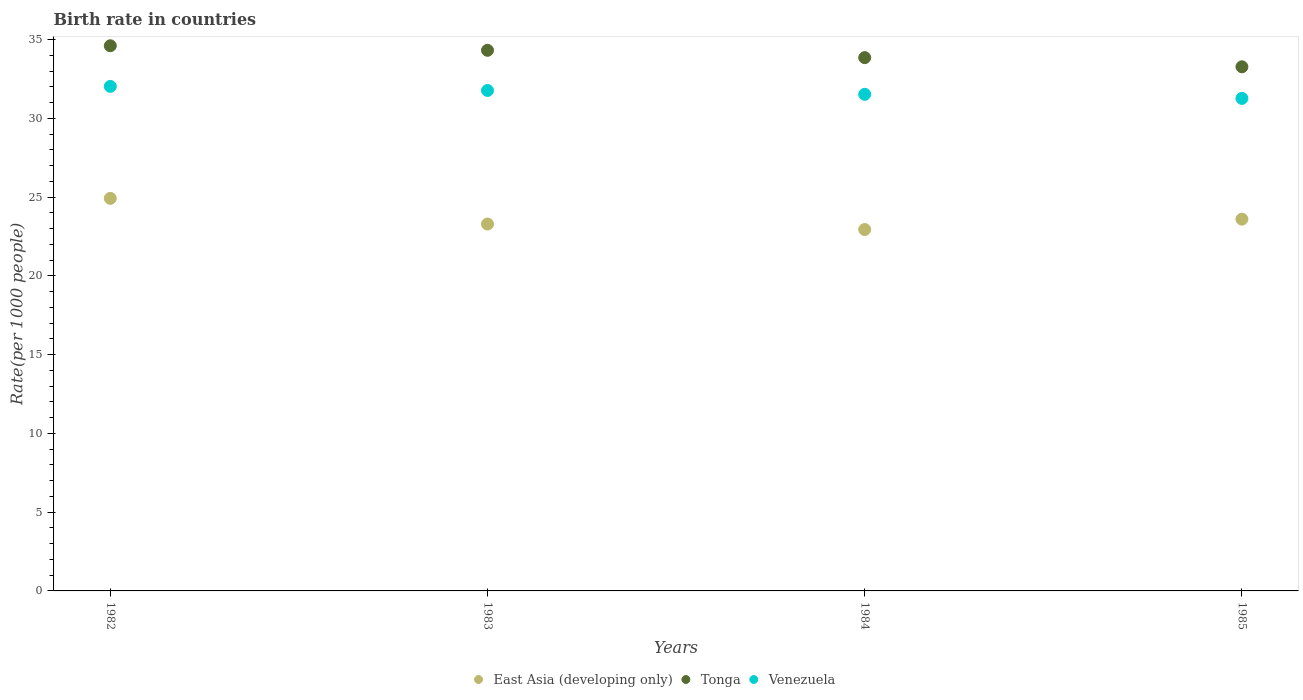How many different coloured dotlines are there?
Keep it short and to the point. 3. What is the birth rate in Tonga in 1983?
Your answer should be compact. 34.32. Across all years, what is the maximum birth rate in Venezuela?
Give a very brief answer. 32.03. Across all years, what is the minimum birth rate in Venezuela?
Offer a terse response. 31.27. In which year was the birth rate in Venezuela maximum?
Keep it short and to the point. 1982. In which year was the birth rate in Tonga minimum?
Your answer should be very brief. 1985. What is the total birth rate in Tonga in the graph?
Keep it short and to the point. 136.06. What is the difference between the birth rate in East Asia (developing only) in 1983 and that in 1985?
Provide a short and direct response. -0.31. What is the difference between the birth rate in Venezuela in 1984 and the birth rate in Tonga in 1982?
Your answer should be compact. -3.08. What is the average birth rate in Venezuela per year?
Your answer should be compact. 31.65. In the year 1983, what is the difference between the birth rate in Venezuela and birth rate in East Asia (developing only)?
Give a very brief answer. 8.48. What is the ratio of the birth rate in East Asia (developing only) in 1982 to that in 1985?
Provide a short and direct response. 1.06. Is the birth rate in Tonga in 1983 less than that in 1984?
Keep it short and to the point. No. Is the difference between the birth rate in Venezuela in 1982 and 1985 greater than the difference between the birth rate in East Asia (developing only) in 1982 and 1985?
Provide a short and direct response. No. What is the difference between the highest and the second highest birth rate in Tonga?
Keep it short and to the point. 0.29. What is the difference between the highest and the lowest birth rate in East Asia (developing only)?
Give a very brief answer. 1.98. In how many years, is the birth rate in Tonga greater than the average birth rate in Tonga taken over all years?
Your answer should be compact. 2. Is the sum of the birth rate in Tonga in 1982 and 1983 greater than the maximum birth rate in East Asia (developing only) across all years?
Ensure brevity in your answer.  Yes. Is it the case that in every year, the sum of the birth rate in Tonga and birth rate in East Asia (developing only)  is greater than the birth rate in Venezuela?
Provide a succinct answer. Yes. Does the birth rate in Tonga monotonically increase over the years?
Offer a terse response. No. How many dotlines are there?
Give a very brief answer. 3. How many years are there in the graph?
Make the answer very short. 4. Are the values on the major ticks of Y-axis written in scientific E-notation?
Your answer should be very brief. No. Where does the legend appear in the graph?
Provide a succinct answer. Bottom center. How are the legend labels stacked?
Offer a terse response. Horizontal. What is the title of the graph?
Your answer should be compact. Birth rate in countries. Does "Mozambique" appear as one of the legend labels in the graph?
Provide a succinct answer. No. What is the label or title of the Y-axis?
Offer a very short reply. Rate(per 1000 people). What is the Rate(per 1000 people) of East Asia (developing only) in 1982?
Your answer should be very brief. 24.92. What is the Rate(per 1000 people) of Tonga in 1982?
Provide a succinct answer. 34.61. What is the Rate(per 1000 people) of Venezuela in 1982?
Give a very brief answer. 32.03. What is the Rate(per 1000 people) of East Asia (developing only) in 1983?
Keep it short and to the point. 23.29. What is the Rate(per 1000 people) of Tonga in 1983?
Ensure brevity in your answer.  34.32. What is the Rate(per 1000 people) of Venezuela in 1983?
Make the answer very short. 31.77. What is the Rate(per 1000 people) in East Asia (developing only) in 1984?
Provide a short and direct response. 22.94. What is the Rate(per 1000 people) of Tonga in 1984?
Give a very brief answer. 33.86. What is the Rate(per 1000 people) in Venezuela in 1984?
Keep it short and to the point. 31.53. What is the Rate(per 1000 people) of East Asia (developing only) in 1985?
Give a very brief answer. 23.6. What is the Rate(per 1000 people) of Tonga in 1985?
Offer a very short reply. 33.27. What is the Rate(per 1000 people) in Venezuela in 1985?
Provide a short and direct response. 31.27. Across all years, what is the maximum Rate(per 1000 people) of East Asia (developing only)?
Keep it short and to the point. 24.92. Across all years, what is the maximum Rate(per 1000 people) in Tonga?
Provide a succinct answer. 34.61. Across all years, what is the maximum Rate(per 1000 people) of Venezuela?
Provide a succinct answer. 32.03. Across all years, what is the minimum Rate(per 1000 people) of East Asia (developing only)?
Your answer should be very brief. 22.94. Across all years, what is the minimum Rate(per 1000 people) in Tonga?
Your response must be concise. 33.27. Across all years, what is the minimum Rate(per 1000 people) of Venezuela?
Offer a terse response. 31.27. What is the total Rate(per 1000 people) in East Asia (developing only) in the graph?
Keep it short and to the point. 94.76. What is the total Rate(per 1000 people) of Tonga in the graph?
Provide a short and direct response. 136.06. What is the total Rate(per 1000 people) in Venezuela in the graph?
Make the answer very short. 126.6. What is the difference between the Rate(per 1000 people) of East Asia (developing only) in 1982 and that in 1983?
Your answer should be very brief. 1.63. What is the difference between the Rate(per 1000 people) in Tonga in 1982 and that in 1983?
Provide a short and direct response. 0.29. What is the difference between the Rate(per 1000 people) in Venezuela in 1982 and that in 1983?
Your answer should be very brief. 0.26. What is the difference between the Rate(per 1000 people) of East Asia (developing only) in 1982 and that in 1984?
Offer a terse response. 1.98. What is the difference between the Rate(per 1000 people) of Tonga in 1982 and that in 1984?
Provide a succinct answer. 0.75. What is the difference between the Rate(per 1000 people) in Venezuela in 1982 and that in 1984?
Your response must be concise. 0.5. What is the difference between the Rate(per 1000 people) in East Asia (developing only) in 1982 and that in 1985?
Offer a terse response. 1.32. What is the difference between the Rate(per 1000 people) in Tonga in 1982 and that in 1985?
Provide a succinct answer. 1.33. What is the difference between the Rate(per 1000 people) of Venezuela in 1982 and that in 1985?
Your answer should be compact. 0.76. What is the difference between the Rate(per 1000 people) of East Asia (developing only) in 1983 and that in 1984?
Provide a short and direct response. 0.35. What is the difference between the Rate(per 1000 people) of Tonga in 1983 and that in 1984?
Offer a terse response. 0.47. What is the difference between the Rate(per 1000 people) in Venezuela in 1983 and that in 1984?
Provide a short and direct response. 0.24. What is the difference between the Rate(per 1000 people) in East Asia (developing only) in 1983 and that in 1985?
Your answer should be compact. -0.31. What is the difference between the Rate(per 1000 people) of Tonga in 1983 and that in 1985?
Ensure brevity in your answer.  1.05. What is the difference between the Rate(per 1000 people) of Venezuela in 1983 and that in 1985?
Ensure brevity in your answer.  0.5. What is the difference between the Rate(per 1000 people) of East Asia (developing only) in 1984 and that in 1985?
Provide a short and direct response. -0.66. What is the difference between the Rate(per 1000 people) in Tonga in 1984 and that in 1985?
Your answer should be compact. 0.58. What is the difference between the Rate(per 1000 people) in Venezuela in 1984 and that in 1985?
Your response must be concise. 0.26. What is the difference between the Rate(per 1000 people) of East Asia (developing only) in 1982 and the Rate(per 1000 people) of Tonga in 1983?
Offer a very short reply. -9.4. What is the difference between the Rate(per 1000 people) of East Asia (developing only) in 1982 and the Rate(per 1000 people) of Venezuela in 1983?
Your answer should be very brief. -6.85. What is the difference between the Rate(per 1000 people) of Tonga in 1982 and the Rate(per 1000 people) of Venezuela in 1983?
Give a very brief answer. 2.84. What is the difference between the Rate(per 1000 people) of East Asia (developing only) in 1982 and the Rate(per 1000 people) of Tonga in 1984?
Provide a succinct answer. -8.93. What is the difference between the Rate(per 1000 people) in East Asia (developing only) in 1982 and the Rate(per 1000 people) in Venezuela in 1984?
Offer a very short reply. -6.6. What is the difference between the Rate(per 1000 people) in Tonga in 1982 and the Rate(per 1000 people) in Venezuela in 1984?
Provide a succinct answer. 3.08. What is the difference between the Rate(per 1000 people) in East Asia (developing only) in 1982 and the Rate(per 1000 people) in Tonga in 1985?
Offer a very short reply. -8.35. What is the difference between the Rate(per 1000 people) of East Asia (developing only) in 1982 and the Rate(per 1000 people) of Venezuela in 1985?
Provide a short and direct response. -6.35. What is the difference between the Rate(per 1000 people) of Tonga in 1982 and the Rate(per 1000 people) of Venezuela in 1985?
Give a very brief answer. 3.34. What is the difference between the Rate(per 1000 people) in East Asia (developing only) in 1983 and the Rate(per 1000 people) in Tonga in 1984?
Offer a terse response. -10.57. What is the difference between the Rate(per 1000 people) in East Asia (developing only) in 1983 and the Rate(per 1000 people) in Venezuela in 1984?
Offer a terse response. -8.24. What is the difference between the Rate(per 1000 people) in Tonga in 1983 and the Rate(per 1000 people) in Venezuela in 1984?
Give a very brief answer. 2.79. What is the difference between the Rate(per 1000 people) in East Asia (developing only) in 1983 and the Rate(per 1000 people) in Tonga in 1985?
Give a very brief answer. -9.98. What is the difference between the Rate(per 1000 people) of East Asia (developing only) in 1983 and the Rate(per 1000 people) of Venezuela in 1985?
Provide a short and direct response. -7.98. What is the difference between the Rate(per 1000 people) in Tonga in 1983 and the Rate(per 1000 people) in Venezuela in 1985?
Your answer should be very brief. 3.05. What is the difference between the Rate(per 1000 people) in East Asia (developing only) in 1984 and the Rate(per 1000 people) in Tonga in 1985?
Provide a short and direct response. -10.33. What is the difference between the Rate(per 1000 people) of East Asia (developing only) in 1984 and the Rate(per 1000 people) of Venezuela in 1985?
Make the answer very short. -8.33. What is the difference between the Rate(per 1000 people) in Tonga in 1984 and the Rate(per 1000 people) in Venezuela in 1985?
Keep it short and to the point. 2.59. What is the average Rate(per 1000 people) in East Asia (developing only) per year?
Make the answer very short. 23.69. What is the average Rate(per 1000 people) in Tonga per year?
Provide a short and direct response. 34.02. What is the average Rate(per 1000 people) of Venezuela per year?
Provide a succinct answer. 31.65. In the year 1982, what is the difference between the Rate(per 1000 people) in East Asia (developing only) and Rate(per 1000 people) in Tonga?
Ensure brevity in your answer.  -9.69. In the year 1982, what is the difference between the Rate(per 1000 people) in East Asia (developing only) and Rate(per 1000 people) in Venezuela?
Keep it short and to the point. -7.11. In the year 1982, what is the difference between the Rate(per 1000 people) in Tonga and Rate(per 1000 people) in Venezuela?
Your answer should be very brief. 2.58. In the year 1983, what is the difference between the Rate(per 1000 people) in East Asia (developing only) and Rate(per 1000 people) in Tonga?
Give a very brief answer. -11.03. In the year 1983, what is the difference between the Rate(per 1000 people) in East Asia (developing only) and Rate(per 1000 people) in Venezuela?
Provide a short and direct response. -8.48. In the year 1983, what is the difference between the Rate(per 1000 people) of Tonga and Rate(per 1000 people) of Venezuela?
Provide a succinct answer. 2.55. In the year 1984, what is the difference between the Rate(per 1000 people) of East Asia (developing only) and Rate(per 1000 people) of Tonga?
Offer a very short reply. -10.91. In the year 1984, what is the difference between the Rate(per 1000 people) in East Asia (developing only) and Rate(per 1000 people) in Venezuela?
Your answer should be compact. -8.58. In the year 1984, what is the difference between the Rate(per 1000 people) in Tonga and Rate(per 1000 people) in Venezuela?
Your answer should be very brief. 2.33. In the year 1985, what is the difference between the Rate(per 1000 people) of East Asia (developing only) and Rate(per 1000 people) of Tonga?
Provide a short and direct response. -9.67. In the year 1985, what is the difference between the Rate(per 1000 people) in East Asia (developing only) and Rate(per 1000 people) in Venezuela?
Offer a very short reply. -7.67. In the year 1985, what is the difference between the Rate(per 1000 people) in Tonga and Rate(per 1000 people) in Venezuela?
Offer a very short reply. 2.01. What is the ratio of the Rate(per 1000 people) of East Asia (developing only) in 1982 to that in 1983?
Make the answer very short. 1.07. What is the ratio of the Rate(per 1000 people) of Tonga in 1982 to that in 1983?
Ensure brevity in your answer.  1.01. What is the ratio of the Rate(per 1000 people) in Venezuela in 1982 to that in 1983?
Make the answer very short. 1.01. What is the ratio of the Rate(per 1000 people) in East Asia (developing only) in 1982 to that in 1984?
Your answer should be very brief. 1.09. What is the ratio of the Rate(per 1000 people) of Tonga in 1982 to that in 1984?
Your answer should be compact. 1.02. What is the ratio of the Rate(per 1000 people) of East Asia (developing only) in 1982 to that in 1985?
Provide a succinct answer. 1.06. What is the ratio of the Rate(per 1000 people) in Tonga in 1982 to that in 1985?
Your answer should be very brief. 1.04. What is the ratio of the Rate(per 1000 people) of Venezuela in 1982 to that in 1985?
Your answer should be compact. 1.02. What is the ratio of the Rate(per 1000 people) in East Asia (developing only) in 1983 to that in 1984?
Give a very brief answer. 1.02. What is the ratio of the Rate(per 1000 people) of Tonga in 1983 to that in 1984?
Your answer should be very brief. 1.01. What is the ratio of the Rate(per 1000 people) of Venezuela in 1983 to that in 1984?
Keep it short and to the point. 1.01. What is the ratio of the Rate(per 1000 people) in Tonga in 1983 to that in 1985?
Your answer should be compact. 1.03. What is the ratio of the Rate(per 1000 people) in Venezuela in 1983 to that in 1985?
Offer a very short reply. 1.02. What is the ratio of the Rate(per 1000 people) in East Asia (developing only) in 1984 to that in 1985?
Make the answer very short. 0.97. What is the ratio of the Rate(per 1000 people) of Tonga in 1984 to that in 1985?
Ensure brevity in your answer.  1.02. What is the ratio of the Rate(per 1000 people) in Venezuela in 1984 to that in 1985?
Your response must be concise. 1.01. What is the difference between the highest and the second highest Rate(per 1000 people) of East Asia (developing only)?
Your answer should be compact. 1.32. What is the difference between the highest and the second highest Rate(per 1000 people) in Tonga?
Offer a very short reply. 0.29. What is the difference between the highest and the second highest Rate(per 1000 people) of Venezuela?
Your answer should be compact. 0.26. What is the difference between the highest and the lowest Rate(per 1000 people) of East Asia (developing only)?
Your answer should be compact. 1.98. What is the difference between the highest and the lowest Rate(per 1000 people) in Tonga?
Offer a very short reply. 1.33. What is the difference between the highest and the lowest Rate(per 1000 people) in Venezuela?
Offer a terse response. 0.76. 